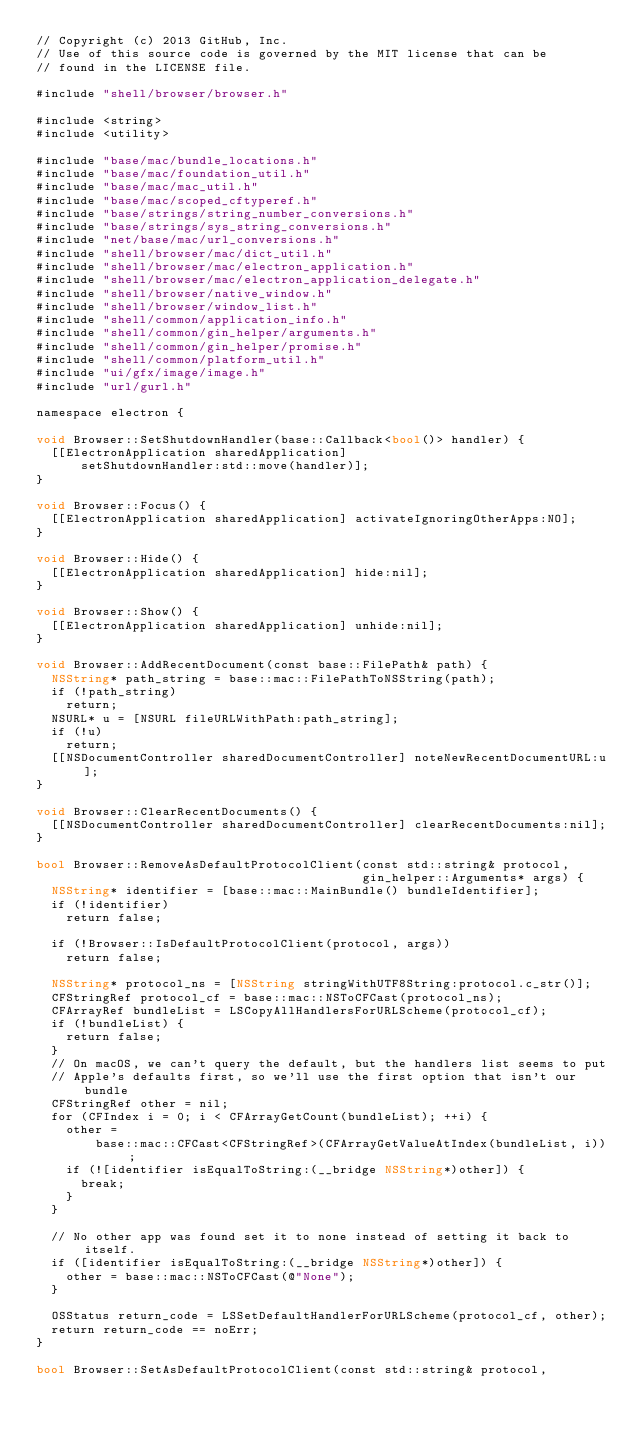Convert code to text. <code><loc_0><loc_0><loc_500><loc_500><_ObjectiveC_>// Copyright (c) 2013 GitHub, Inc.
// Use of this source code is governed by the MIT license that can be
// found in the LICENSE file.

#include "shell/browser/browser.h"

#include <string>
#include <utility>

#include "base/mac/bundle_locations.h"
#include "base/mac/foundation_util.h"
#include "base/mac/mac_util.h"
#include "base/mac/scoped_cftyperef.h"
#include "base/strings/string_number_conversions.h"
#include "base/strings/sys_string_conversions.h"
#include "net/base/mac/url_conversions.h"
#include "shell/browser/mac/dict_util.h"
#include "shell/browser/mac/electron_application.h"
#include "shell/browser/mac/electron_application_delegate.h"
#include "shell/browser/native_window.h"
#include "shell/browser/window_list.h"
#include "shell/common/application_info.h"
#include "shell/common/gin_helper/arguments.h"
#include "shell/common/gin_helper/promise.h"
#include "shell/common/platform_util.h"
#include "ui/gfx/image/image.h"
#include "url/gurl.h"

namespace electron {

void Browser::SetShutdownHandler(base::Callback<bool()> handler) {
  [[ElectronApplication sharedApplication]
      setShutdownHandler:std::move(handler)];
}

void Browser::Focus() {
  [[ElectronApplication sharedApplication] activateIgnoringOtherApps:NO];
}

void Browser::Hide() {
  [[ElectronApplication sharedApplication] hide:nil];
}

void Browser::Show() {
  [[ElectronApplication sharedApplication] unhide:nil];
}

void Browser::AddRecentDocument(const base::FilePath& path) {
  NSString* path_string = base::mac::FilePathToNSString(path);
  if (!path_string)
    return;
  NSURL* u = [NSURL fileURLWithPath:path_string];
  if (!u)
    return;
  [[NSDocumentController sharedDocumentController] noteNewRecentDocumentURL:u];
}

void Browser::ClearRecentDocuments() {
  [[NSDocumentController sharedDocumentController] clearRecentDocuments:nil];
}

bool Browser::RemoveAsDefaultProtocolClient(const std::string& protocol,
                                            gin_helper::Arguments* args) {
  NSString* identifier = [base::mac::MainBundle() bundleIdentifier];
  if (!identifier)
    return false;

  if (!Browser::IsDefaultProtocolClient(protocol, args))
    return false;

  NSString* protocol_ns = [NSString stringWithUTF8String:protocol.c_str()];
  CFStringRef protocol_cf = base::mac::NSToCFCast(protocol_ns);
  CFArrayRef bundleList = LSCopyAllHandlersForURLScheme(protocol_cf);
  if (!bundleList) {
    return false;
  }
  // On macOS, we can't query the default, but the handlers list seems to put
  // Apple's defaults first, so we'll use the first option that isn't our bundle
  CFStringRef other = nil;
  for (CFIndex i = 0; i < CFArrayGetCount(bundleList); ++i) {
    other =
        base::mac::CFCast<CFStringRef>(CFArrayGetValueAtIndex(bundleList, i));
    if (![identifier isEqualToString:(__bridge NSString*)other]) {
      break;
    }
  }

  // No other app was found set it to none instead of setting it back to itself.
  if ([identifier isEqualToString:(__bridge NSString*)other]) {
    other = base::mac::NSToCFCast(@"None");
  }

  OSStatus return_code = LSSetDefaultHandlerForURLScheme(protocol_cf, other);
  return return_code == noErr;
}

bool Browser::SetAsDefaultProtocolClient(const std::string& protocol,</code> 